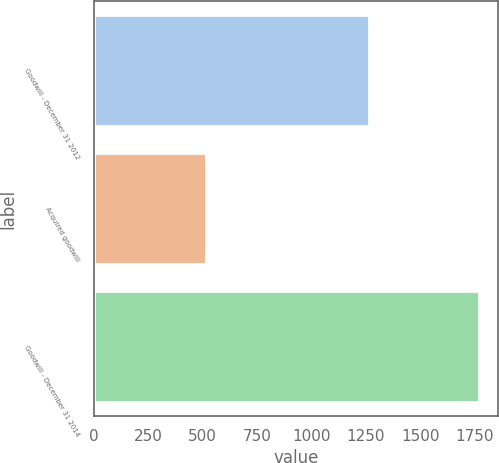Convert chart. <chart><loc_0><loc_0><loc_500><loc_500><bar_chart><fcel>Goodwill - December 31 2012<fcel>Acquired goodwill<fcel>Goodwill - December 31 2014<nl><fcel>1263<fcel>517<fcel>1769<nl></chart> 